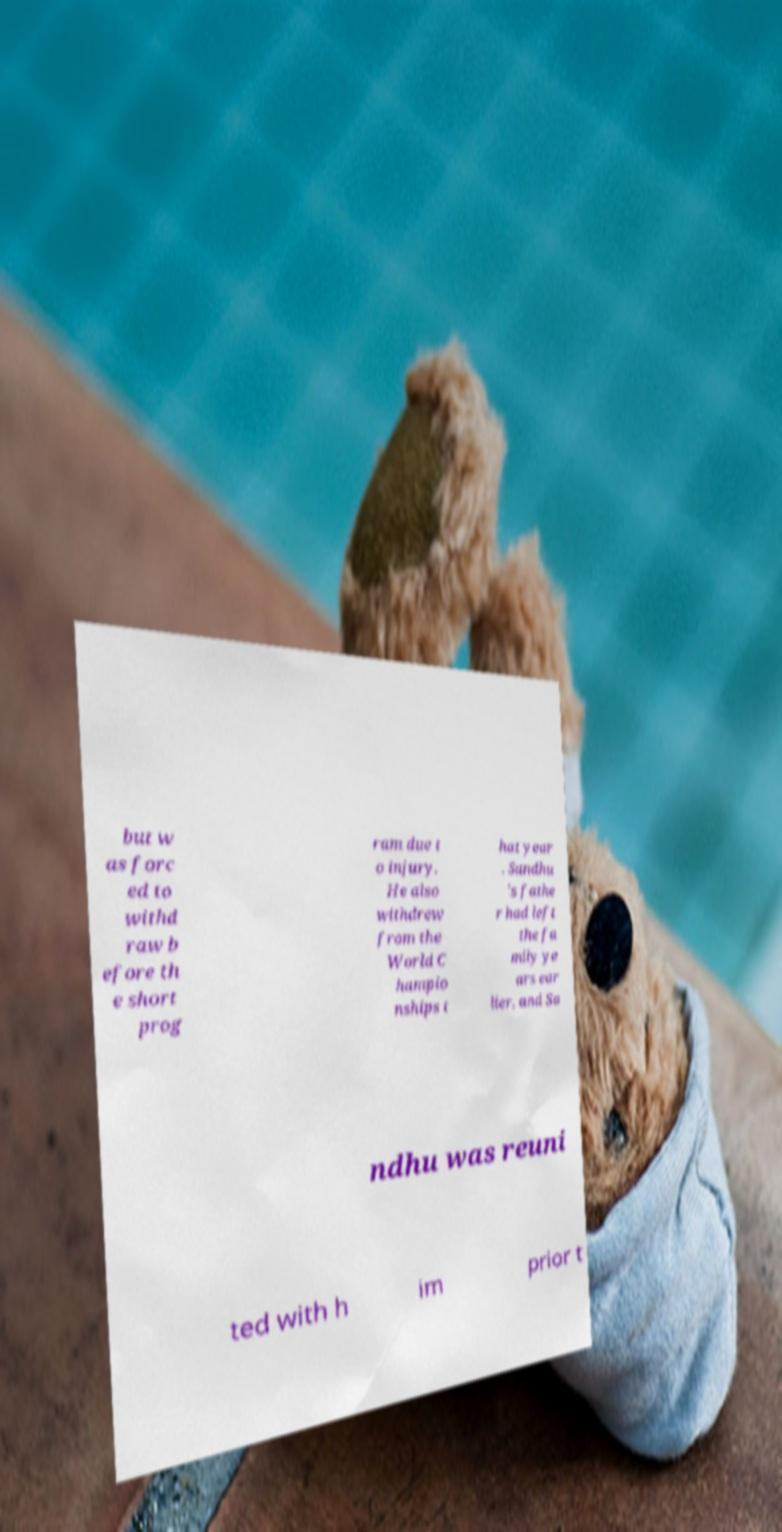Please identify and transcribe the text found in this image. but w as forc ed to withd raw b efore th e short prog ram due t o injury. He also withdrew from the World C hampio nships t hat year . Sandhu 's fathe r had left the fa mily ye ars ear lier, and Sa ndhu was reuni ted with h im prior t 